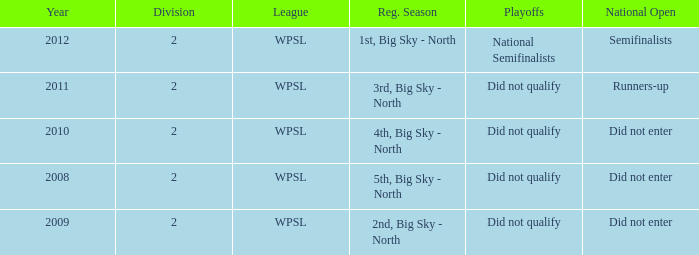Could you parse the entire table? {'header': ['Year', 'Division', 'League', 'Reg. Season', 'Playoffs', 'National Open'], 'rows': [['2012', '2', 'WPSL', '1st, Big Sky - North', 'National Semifinalists', 'Semifinalists'], ['2011', '2', 'WPSL', '3rd, Big Sky - North', 'Did not qualify', 'Runners-up'], ['2010', '2', 'WPSL', '4th, Big Sky - North', 'Did not qualify', 'Did not enter'], ['2008', '2', 'WPSL', '5th, Big Sky - North', 'Did not qualify', 'Did not enter'], ['2009', '2', 'WPSL', '2nd, Big Sky - North', 'Did not qualify', 'Did not enter']]} What is the highest number of divisions mentioned? 2.0. 